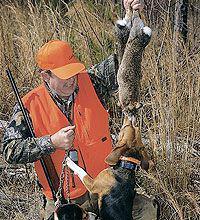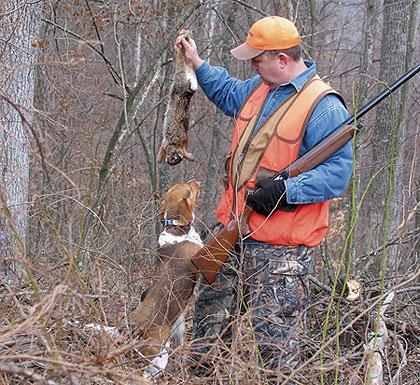The first image is the image on the left, the second image is the image on the right. Assess this claim about the two images: "At least one image shows a man in orange vest and cap holding up a prey animal over a hound dog.". Correct or not? Answer yes or no. Yes. The first image is the image on the left, the second image is the image on the right. Analyze the images presented: Is the assertion "In at least one of the images, a hunter in a bright orange vest and hat holds a dead animal over a beagle" valid? Answer yes or no. Yes. 